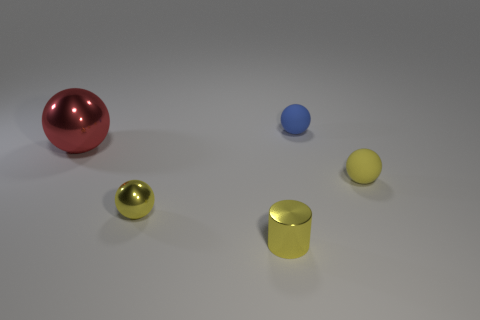Subtract all gray cylinders. How many yellow balls are left? 2 Subtract all blue balls. How many balls are left? 3 Add 5 tiny blue spheres. How many objects exist? 10 Subtract all tiny yellow metallic balls. How many balls are left? 3 Subtract 2 balls. How many balls are left? 2 Subtract all spheres. How many objects are left? 1 Subtract all cyan spheres. Subtract all red blocks. How many spheres are left? 4 Add 4 tiny yellow objects. How many tiny yellow objects are left? 7 Add 4 tiny spheres. How many tiny spheres exist? 7 Subtract 0 red cubes. How many objects are left? 5 